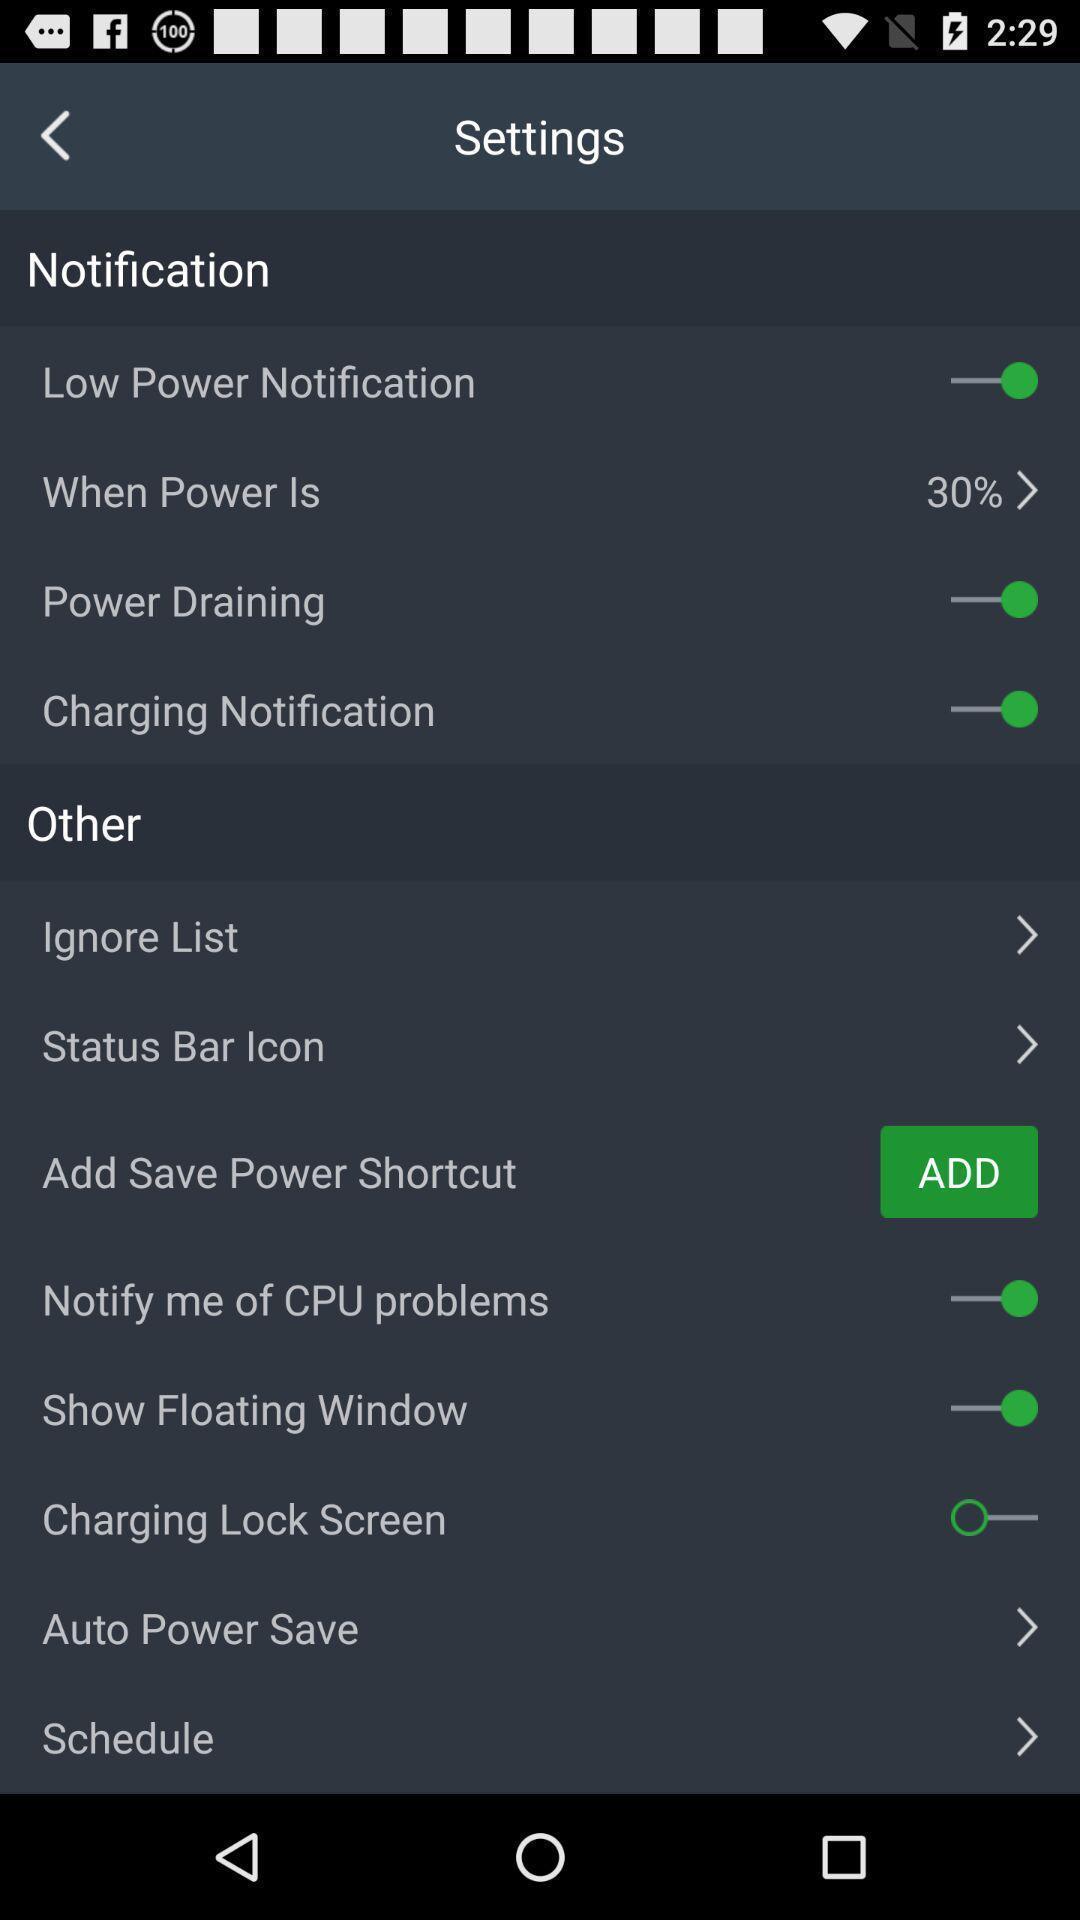Give me a summary of this screen capture. Settings page. 